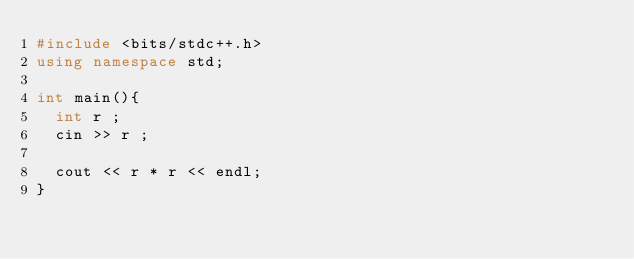<code> <loc_0><loc_0><loc_500><loc_500><_C++_>#include <bits/stdc++.h>
using namespace std;

int main(){
  int r ;
  cin >> r ;
  
  cout << r * r << endl;
}
</code> 